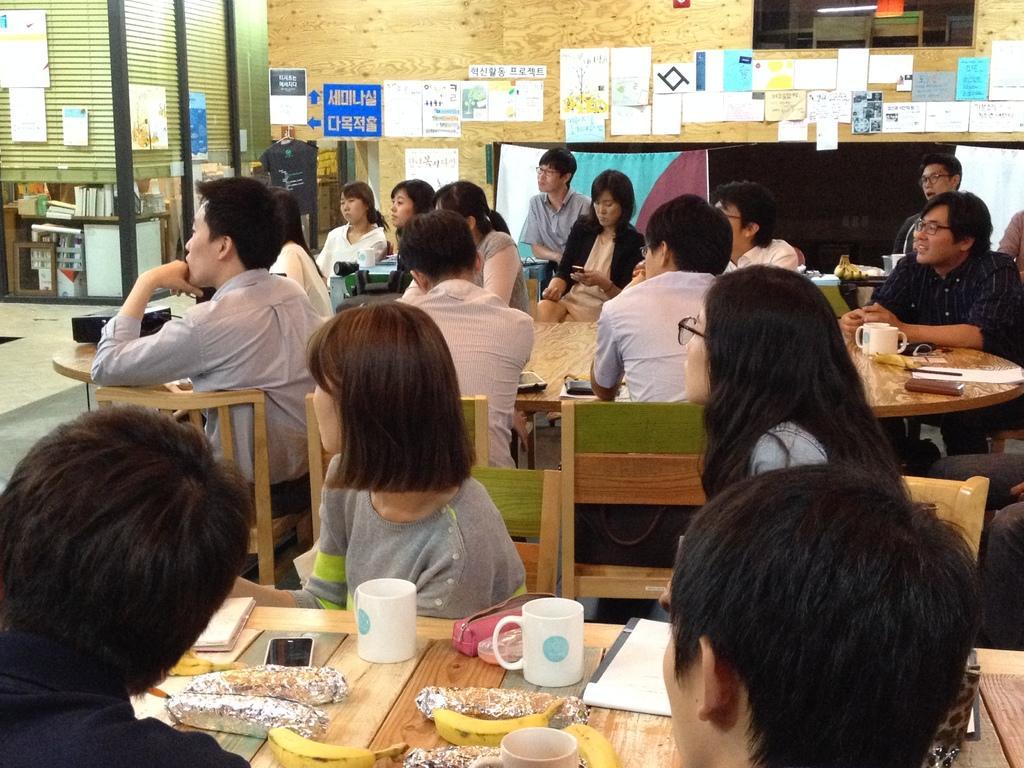Describe this image in one or two sentences. In this picture we can see some people are sitting on chairs in front of tables, there are mugs, bananas, a mobile phone, a file and some food on this table, in the background there is a wall, we can see some papers pasted on the wall, on the left side there are some books and a projector. 